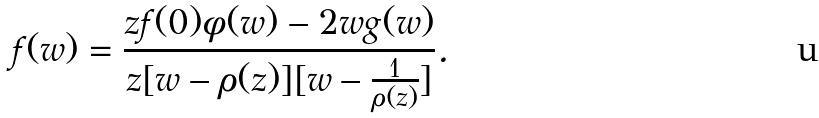<formula> <loc_0><loc_0><loc_500><loc_500>f ( w ) = \frac { z f ( 0 ) \phi ( w ) - 2 w g ( w ) } { z [ w - \rho ( z ) ] [ w - \frac { 1 } { \rho ( z ) } ] } .</formula> 